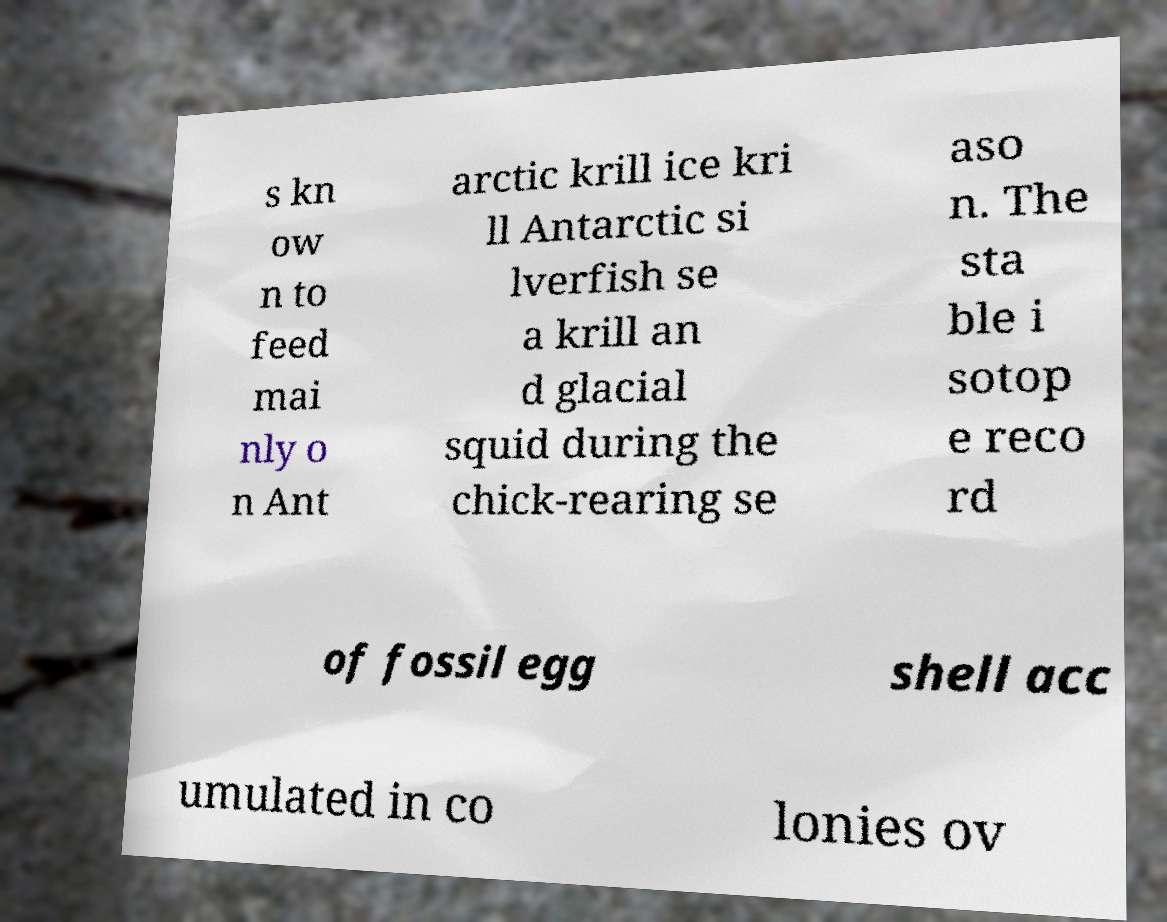Can you accurately transcribe the text from the provided image for me? s kn ow n to feed mai nly o n Ant arctic krill ice kri ll Antarctic si lverfish se a krill an d glacial squid during the chick-rearing se aso n. The sta ble i sotop e reco rd of fossil egg shell acc umulated in co lonies ov 